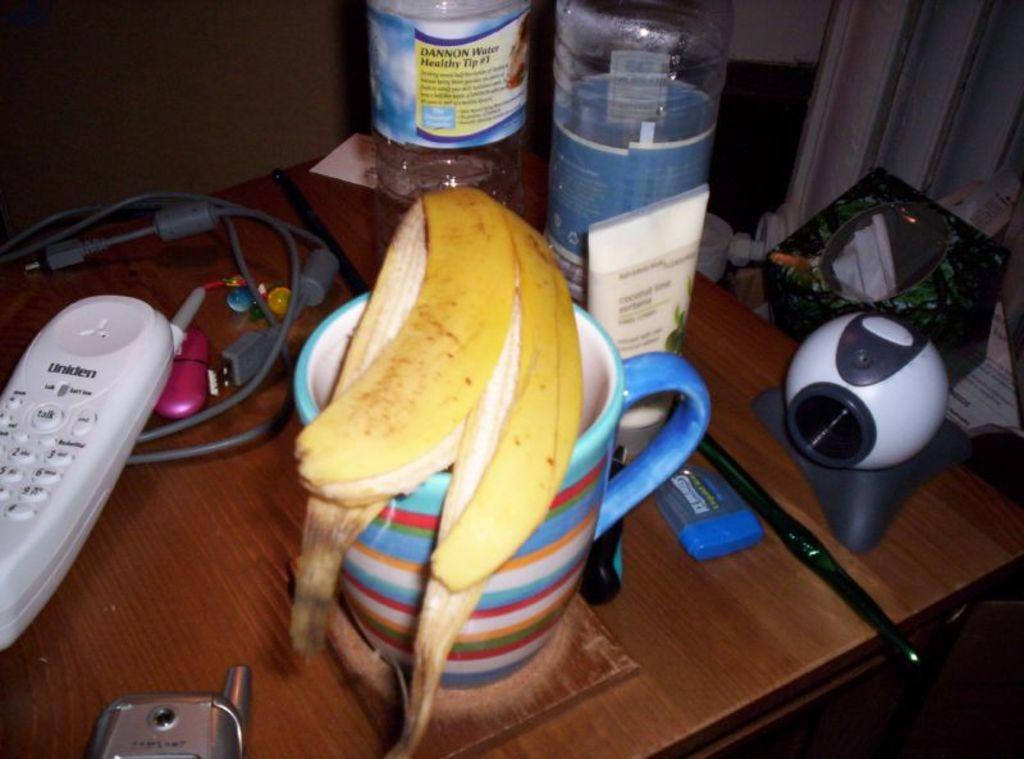What is one of the objects in the image? There is a cup in the image. What type of device can be seen in the image? There is a device in the image. What is used for controlling the device? There is a remote in the image. What connects the device to a power source? There is a cable in the image. What type of communication device is present in the image? There is a cell phone in the image. What type of accessory is in the image? There is a bracelet in the image. What type of food waste is in the image? There is a banana peel in the image. What type of container is in the image? There is a box in the image. What type of beverage containers are on the table in the image? There are bottles on the table in the image. What can be seen in the background of the image? There is a wall in the background of the image. What type of guitar is being played in the image? There is no guitar present in the image. How many pages are in the book on the table in the image? There is no book present in the image. What is the kitten doing in the image? There is no kitten present in the image. 